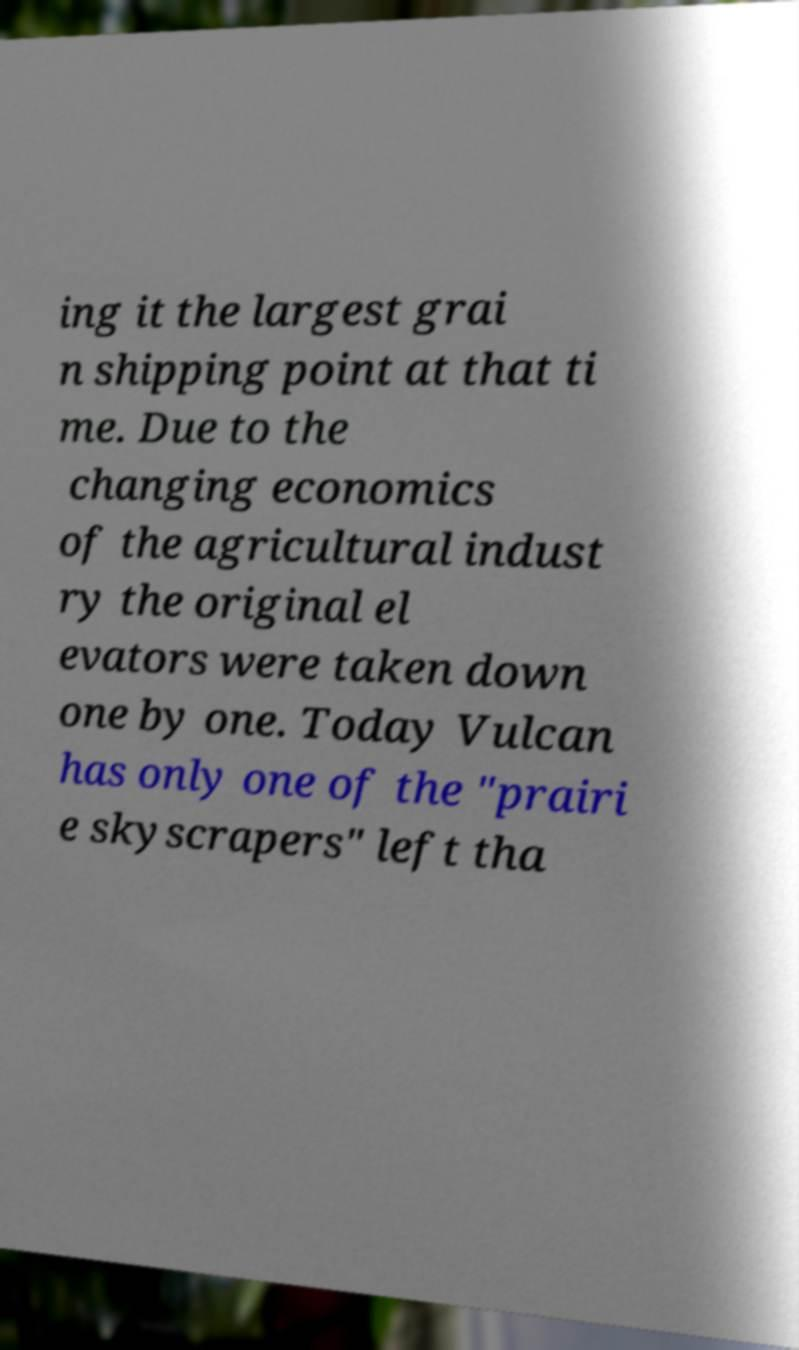What messages or text are displayed in this image? I need them in a readable, typed format. ing it the largest grai n shipping point at that ti me. Due to the changing economics of the agricultural indust ry the original el evators were taken down one by one. Today Vulcan has only one of the "prairi e skyscrapers" left tha 